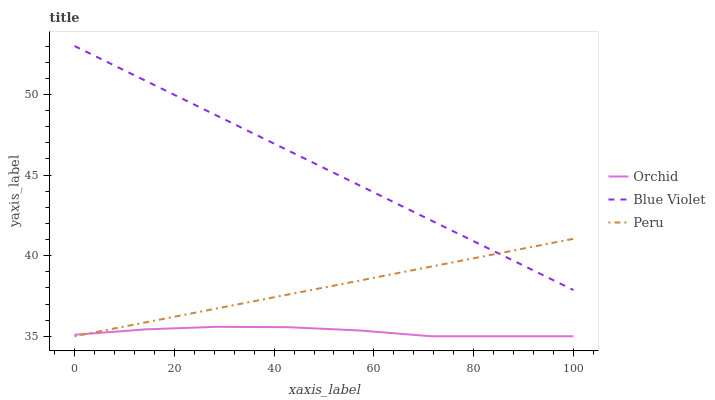Does Blue Violet have the minimum area under the curve?
Answer yes or no. No. Does Orchid have the maximum area under the curve?
Answer yes or no. No. Is Orchid the smoothest?
Answer yes or no. No. Is Blue Violet the roughest?
Answer yes or no. No. Does Blue Violet have the lowest value?
Answer yes or no. No. Does Orchid have the highest value?
Answer yes or no. No. Is Orchid less than Blue Violet?
Answer yes or no. Yes. Is Blue Violet greater than Orchid?
Answer yes or no. Yes. Does Orchid intersect Blue Violet?
Answer yes or no. No. 